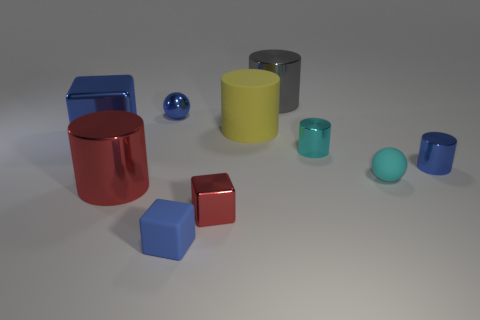Subtract 2 cylinders. How many cylinders are left? 3 Subtract all yellow rubber cylinders. How many cylinders are left? 4 Subtract all yellow cylinders. How many cylinders are left? 4 Subtract all cyan cylinders. Subtract all purple spheres. How many cylinders are left? 4 Subtract all cubes. How many objects are left? 7 Subtract all tiny cyan rubber things. Subtract all tiny blue blocks. How many objects are left? 8 Add 2 tiny red blocks. How many tiny red blocks are left? 3 Add 8 cyan balls. How many cyan balls exist? 9 Subtract 0 yellow balls. How many objects are left? 10 